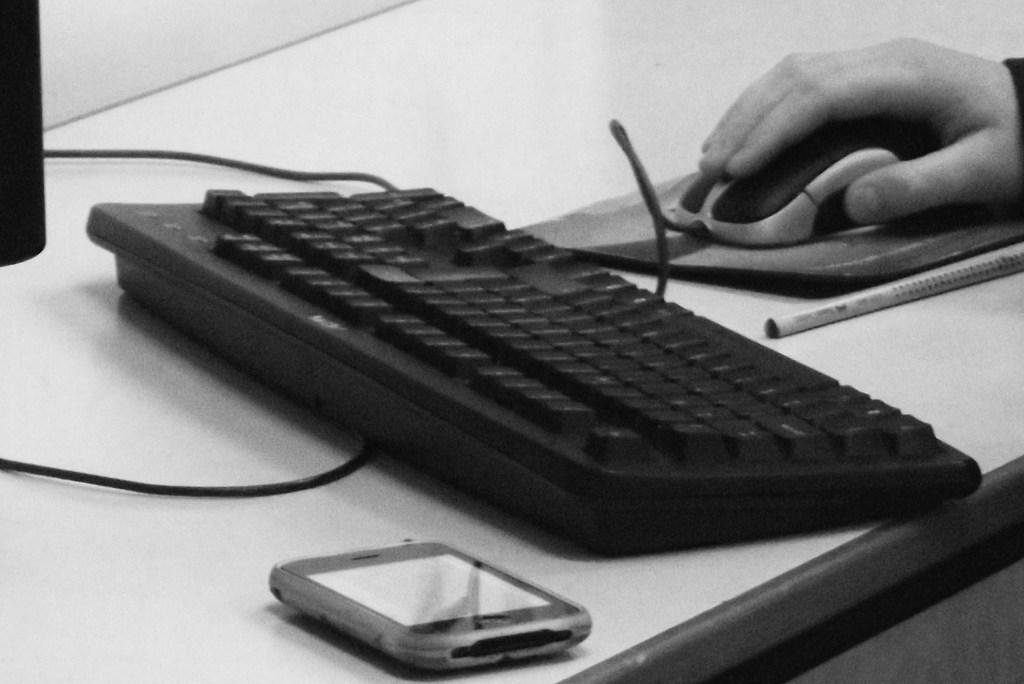What is the main object on the table in the image? There is a keyboard in the image. What other electronic device is present on the table? There is a mobile in the image. What is being held by a person's hand in the image? There is a mouse held by a person's hand in the image. What writing instrument is visible in the image? There is a pen in the image. Where are all these objects located? All these objects are placed on a table. How many lizards can be seen crawling on the keyboard in the image? There are no lizards present in the image; it only features a keyboard, mobile, mouse, and pen on a table. What type of friction is being generated by the mouse on the table in the image? The image does not provide information about the friction generated by the mouse on the table. 